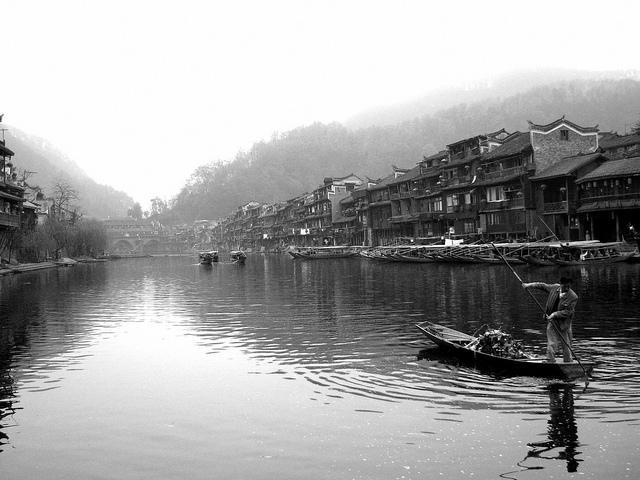How many people are there?
Give a very brief answer. 1. How many cats do you see?
Give a very brief answer. 0. 